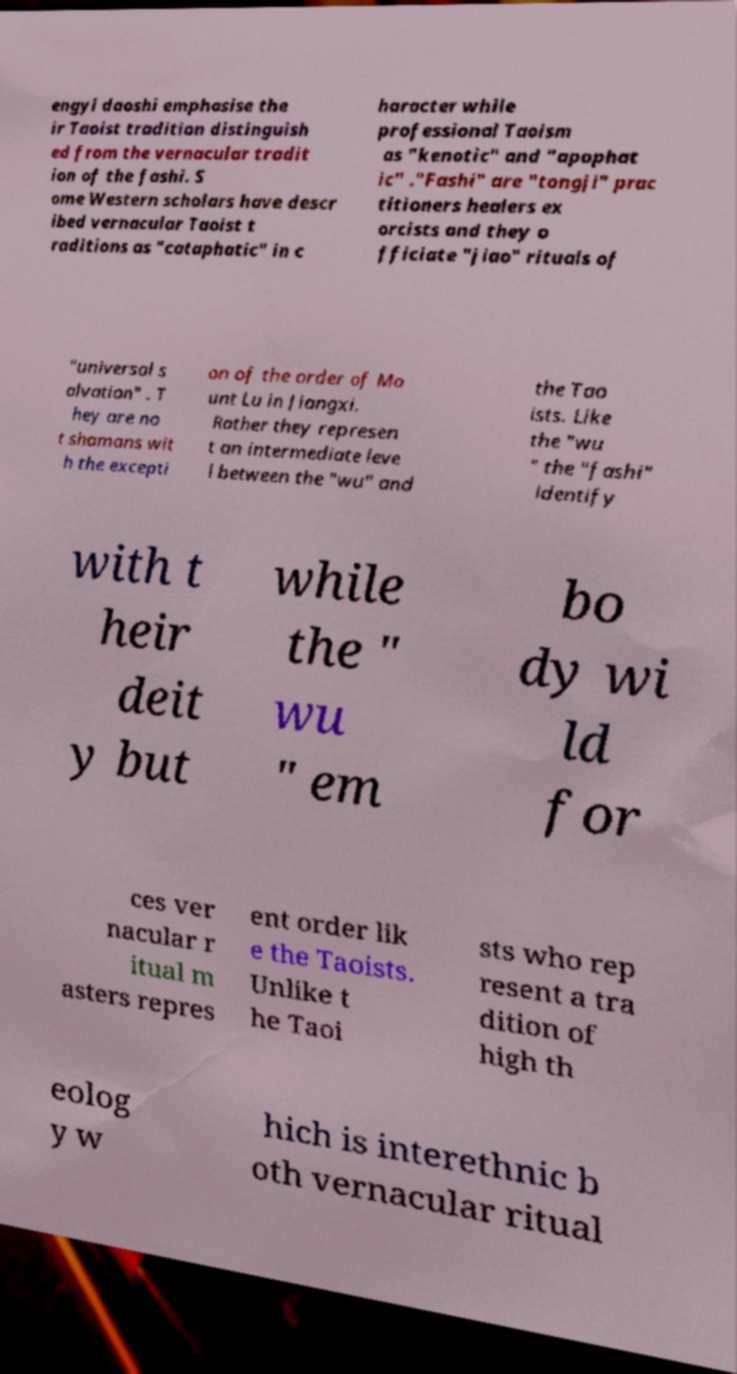Please read and relay the text visible in this image. What does it say? engyi daoshi emphasise the ir Taoist tradition distinguish ed from the vernacular tradit ion of the fashi. S ome Western scholars have descr ibed vernacular Taoist t raditions as "cataphatic" in c haracter while professional Taoism as "kenotic" and "apophat ic" ."Fashi" are "tongji" prac titioners healers ex orcists and they o fficiate "jiao" rituals of "universal s alvation" . T hey are no t shamans wit h the excepti on of the order of Mo unt Lu in Jiangxi. Rather they represen t an intermediate leve l between the "wu" and the Tao ists. Like the "wu " the "fashi" identify with t heir deit y but while the " wu " em bo dy wi ld for ces ver nacular r itual m asters repres ent order lik e the Taoists. Unlike t he Taoi sts who rep resent a tra dition of high th eolog y w hich is interethnic b oth vernacular ritual 